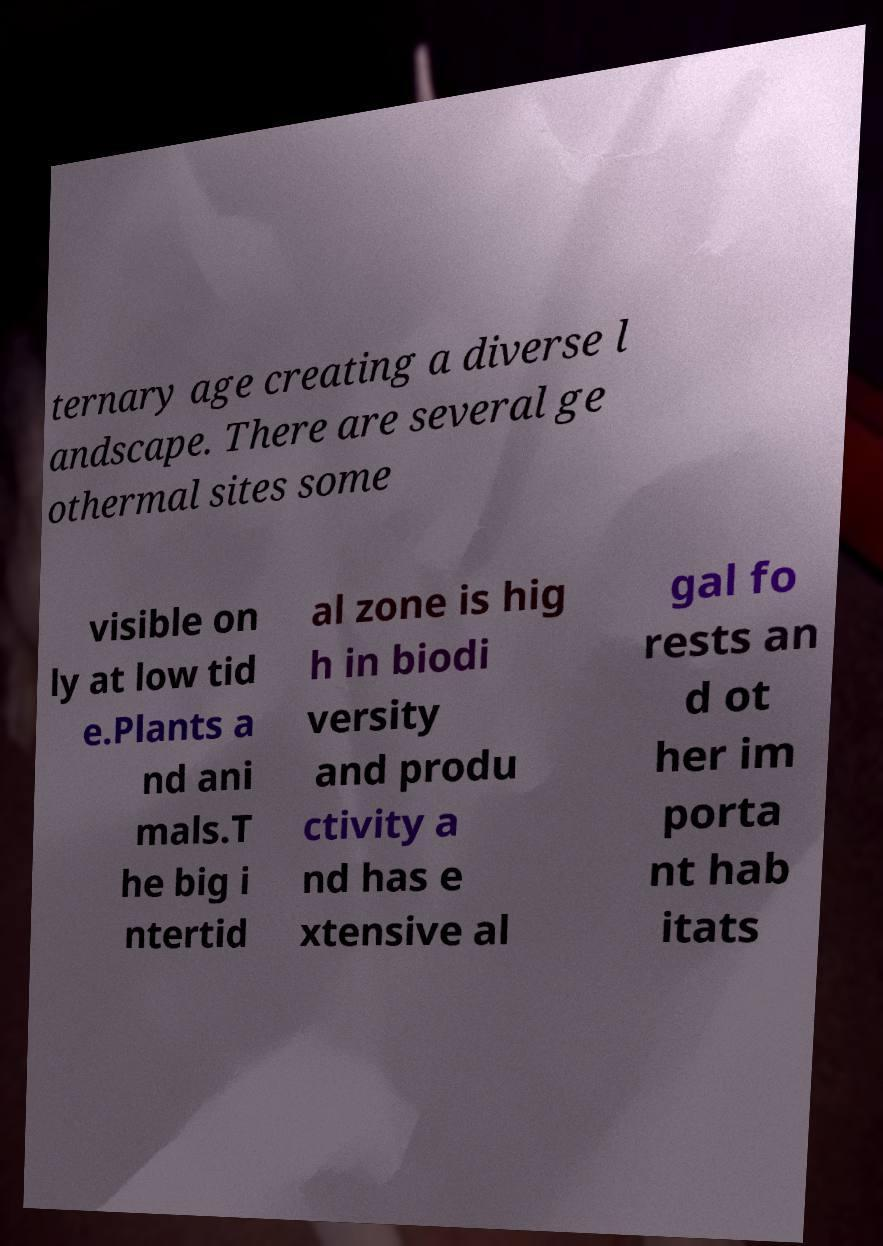Could you assist in decoding the text presented in this image and type it out clearly? ternary age creating a diverse l andscape. There are several ge othermal sites some visible on ly at low tid e.Plants a nd ani mals.T he big i ntertid al zone is hig h in biodi versity and produ ctivity a nd has e xtensive al gal fo rests an d ot her im porta nt hab itats 